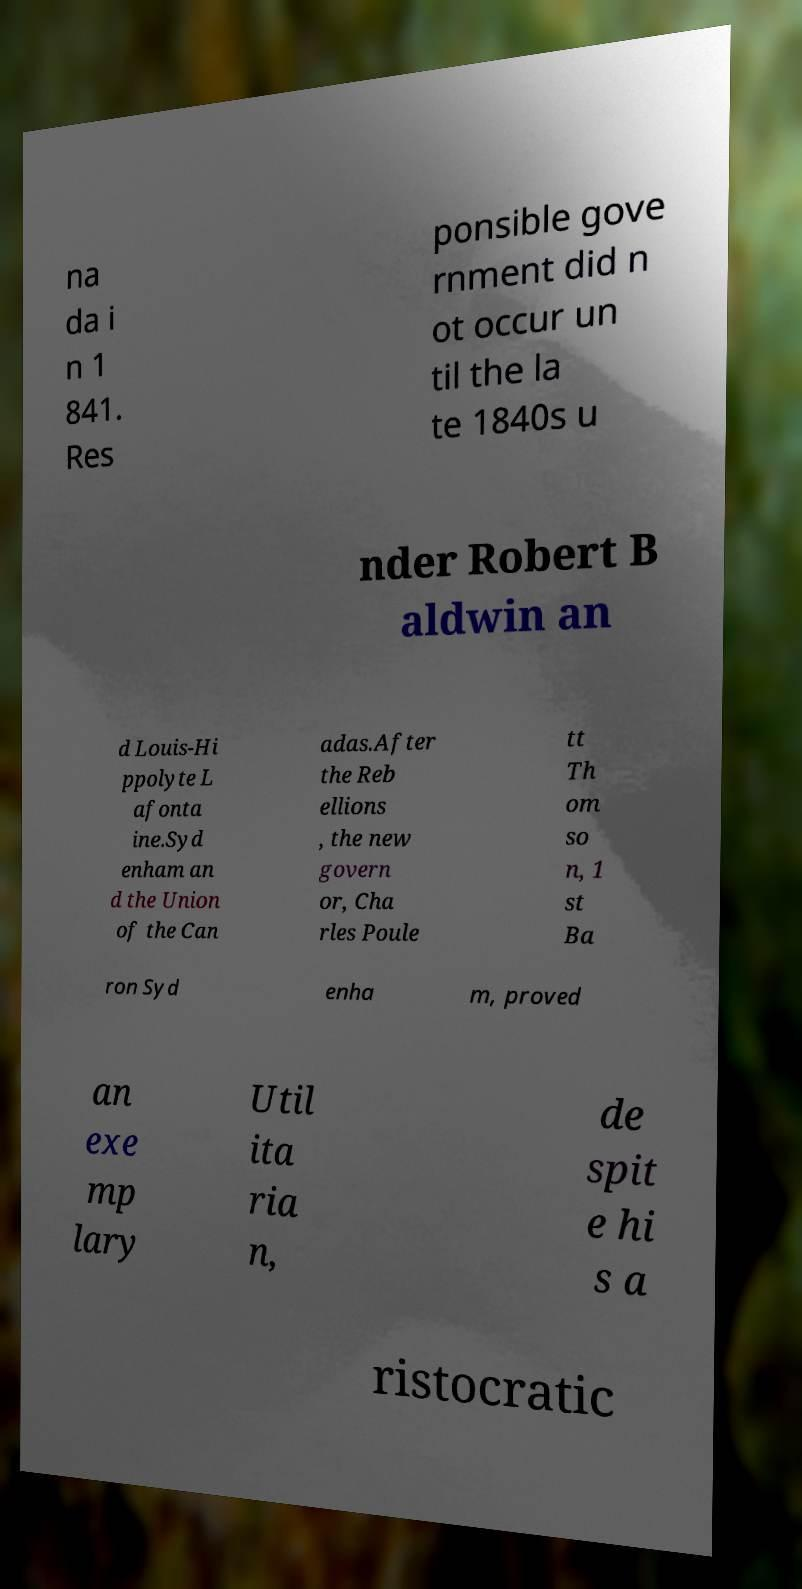What messages or text are displayed in this image? I need them in a readable, typed format. na da i n 1 841. Res ponsible gove rnment did n ot occur un til the la te 1840s u nder Robert B aldwin an d Louis-Hi ppolyte L afonta ine.Syd enham an d the Union of the Can adas.After the Reb ellions , the new govern or, Cha rles Poule tt Th om so n, 1 st Ba ron Syd enha m, proved an exe mp lary Util ita ria n, de spit e hi s a ristocratic 